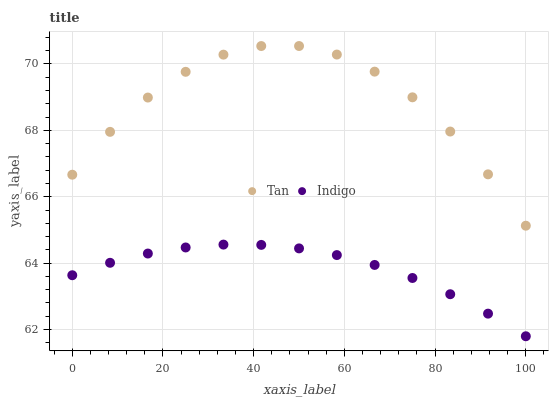Does Indigo have the minimum area under the curve?
Answer yes or no. Yes. Does Tan have the maximum area under the curve?
Answer yes or no. Yes. Does Indigo have the maximum area under the curve?
Answer yes or no. No. Is Indigo the smoothest?
Answer yes or no. Yes. Is Tan the roughest?
Answer yes or no. Yes. Is Indigo the roughest?
Answer yes or no. No. Does Indigo have the lowest value?
Answer yes or no. Yes. Does Tan have the highest value?
Answer yes or no. Yes. Does Indigo have the highest value?
Answer yes or no. No. Is Indigo less than Tan?
Answer yes or no. Yes. Is Tan greater than Indigo?
Answer yes or no. Yes. Does Indigo intersect Tan?
Answer yes or no. No. 